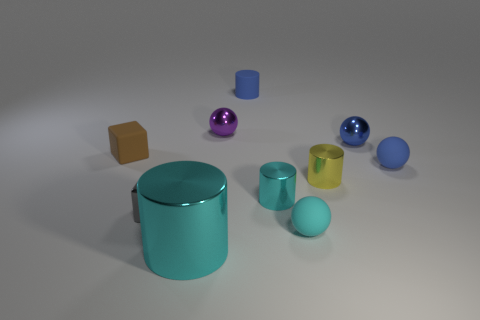There is a rubber thing that is in front of the small blue matte thing in front of the small brown rubber object; is there a matte cube in front of it?
Give a very brief answer. No. What color is the other tiny metallic thing that is the same shape as the tiny purple object?
Keep it short and to the point. Blue. What number of gray things are either tiny metal spheres or rubber cylinders?
Offer a terse response. 0. What is the cylinder that is behind the sphere that is to the left of the tiny blue matte cylinder made of?
Keep it short and to the point. Rubber. Is the shape of the small blue shiny thing the same as the small brown rubber object?
Offer a terse response. No. The rubber block that is the same size as the metallic cube is what color?
Give a very brief answer. Brown. Are there any other objects of the same color as the big metallic object?
Provide a short and direct response. Yes. Is there a thing?
Your answer should be very brief. Yes. Do the tiny cyan thing in front of the gray metal object and the blue cylinder have the same material?
Offer a very short reply. Yes. The shiny thing that is the same color as the small matte cylinder is what size?
Your answer should be very brief. Small. 